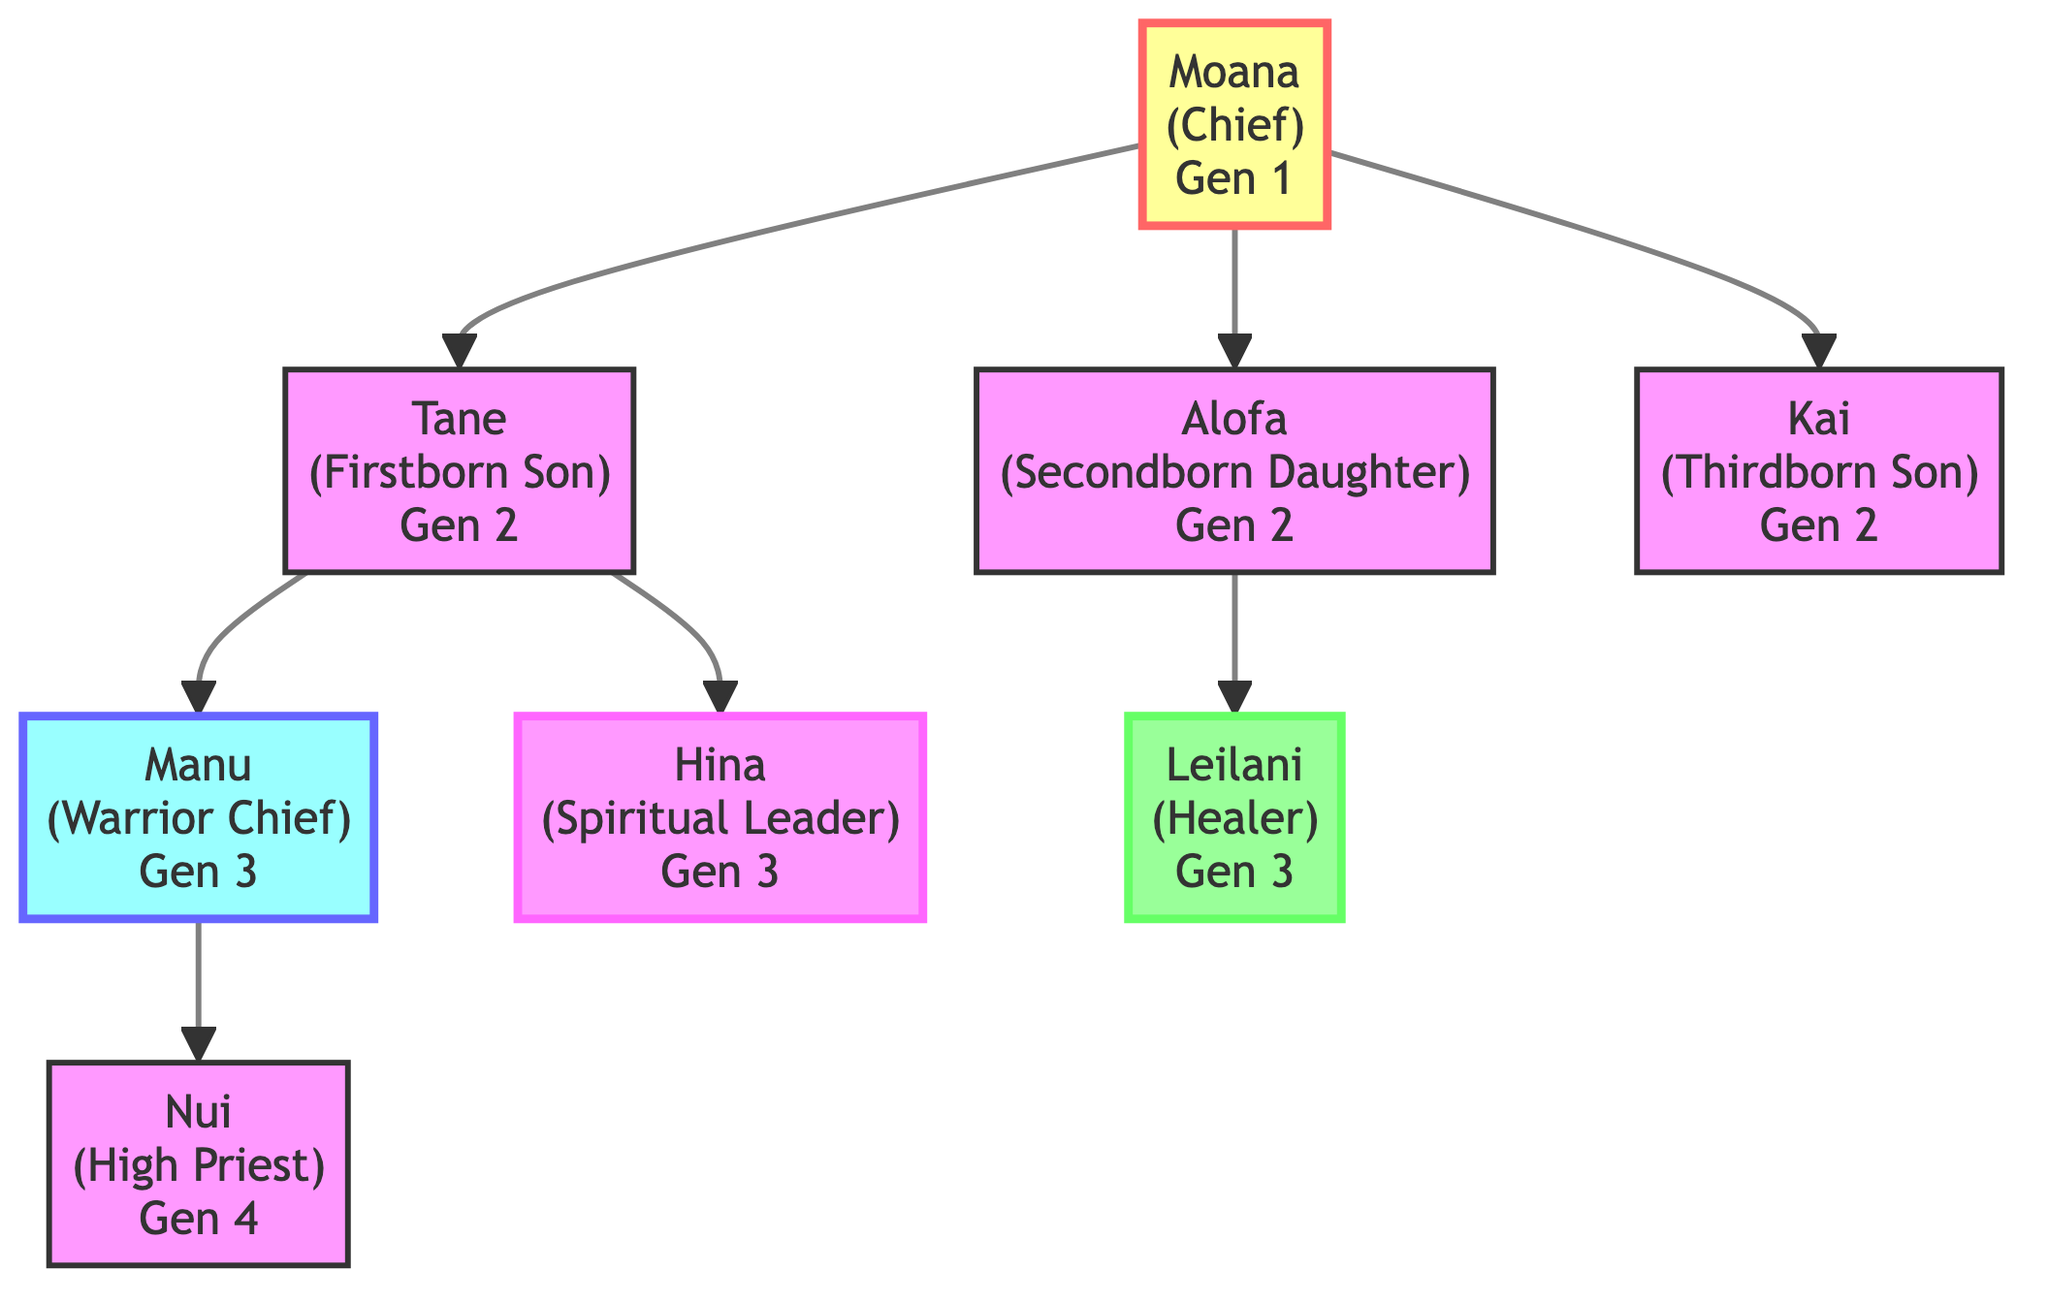What is the role of Moana in the family tree? Moana is identified at the top of the family tree with the label "Moana (Chief)", indicating her role as the chief in generation 1.
Answer: Chief How many children does Tane have? Tane has two children listed in the diagram: Manu and Hina. Thus, counting them gives us the number of Tane's children as 2.
Answer: 2 What is the inheritance rule for Alofa? Alofa's inheritance rule is noted as "Matrilineal Succession," which is directly stated in her part of the family tree.
Answer: Matrilineal Succession Who is the High Priest in generation 4? The diagram shows that Nui is denoted as "Nui (High Priest)" in generation 4, which identifies him as the High Priest.
Answer: Nui What role does Hina play in the family? Looking at Hina's entry in the family tree, she is labeled "Hina (Spiritual Leader)", indicating her role as the spiritual leader in generation 3.
Answer: Spiritual Leader Which node represents the youngest heir based on the rules provided? Kai is marked as "Kai (Thirdborn Son)" with "Youngest Heir" listed under inheritance rules, indicating he is the youngest heir in this lineage.
Answer: Youngest Heir What is the highest generation depicted in the tree? The highest generation shown is 4, represented by the node Nui, who is in generation 4 in the family tree.
Answer: 4 What relationship does Manu have to Tane? Manu is listed as a child of Tane in the diagram, indicating that Manu is Tane's son.
Answer: Son What role does Leilani fulfill in the lineage? Leilani is described in the tree as "Leilani (Healer)", indicating her role as a healer in generation 3.
Answer: Healer 